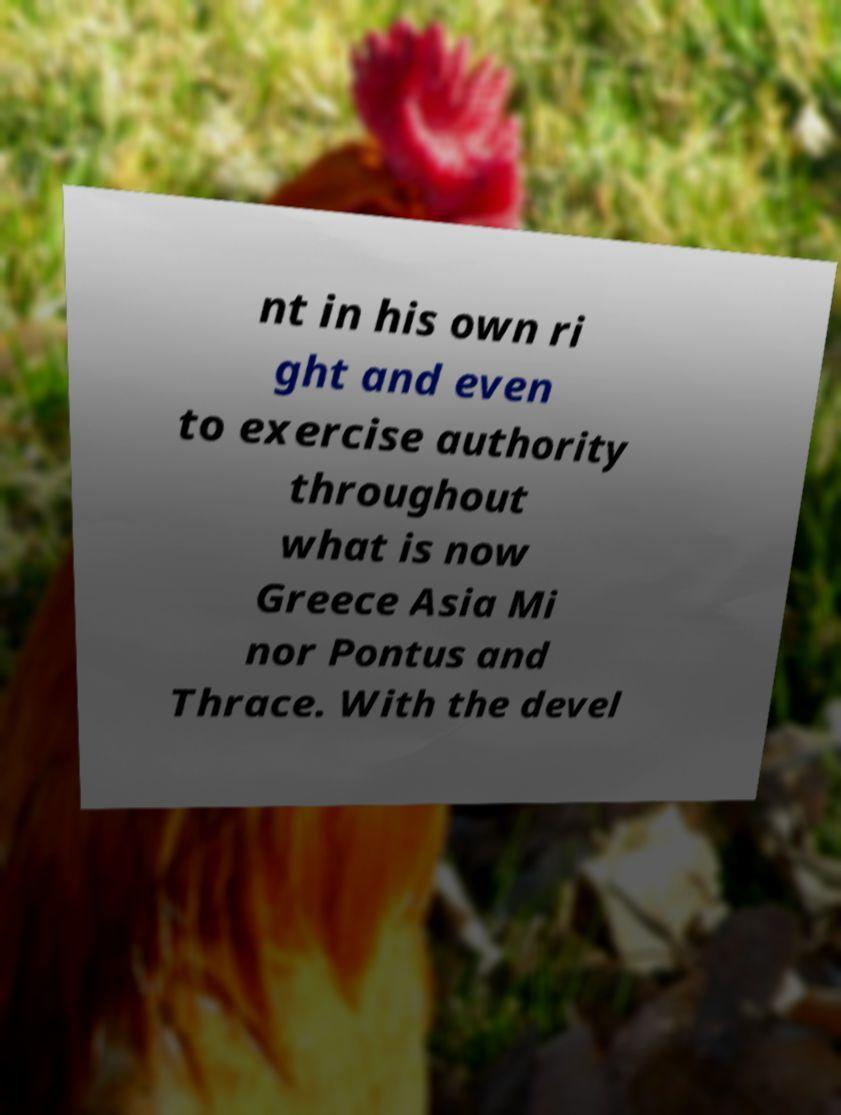There's text embedded in this image that I need extracted. Can you transcribe it verbatim? nt in his own ri ght and even to exercise authority throughout what is now Greece Asia Mi nor Pontus and Thrace. With the devel 